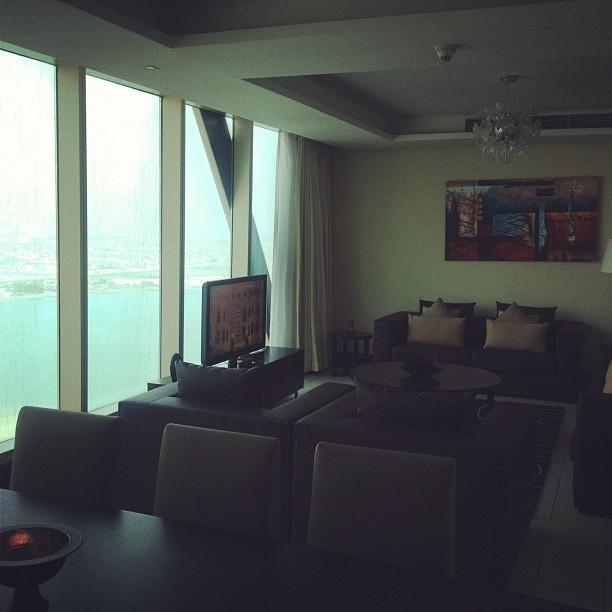How many dining tables can be seen?
Give a very brief answer. 2. How many couches are there?
Give a very brief answer. 2. How many chairs are in the photo?
Give a very brief answer. 4. 